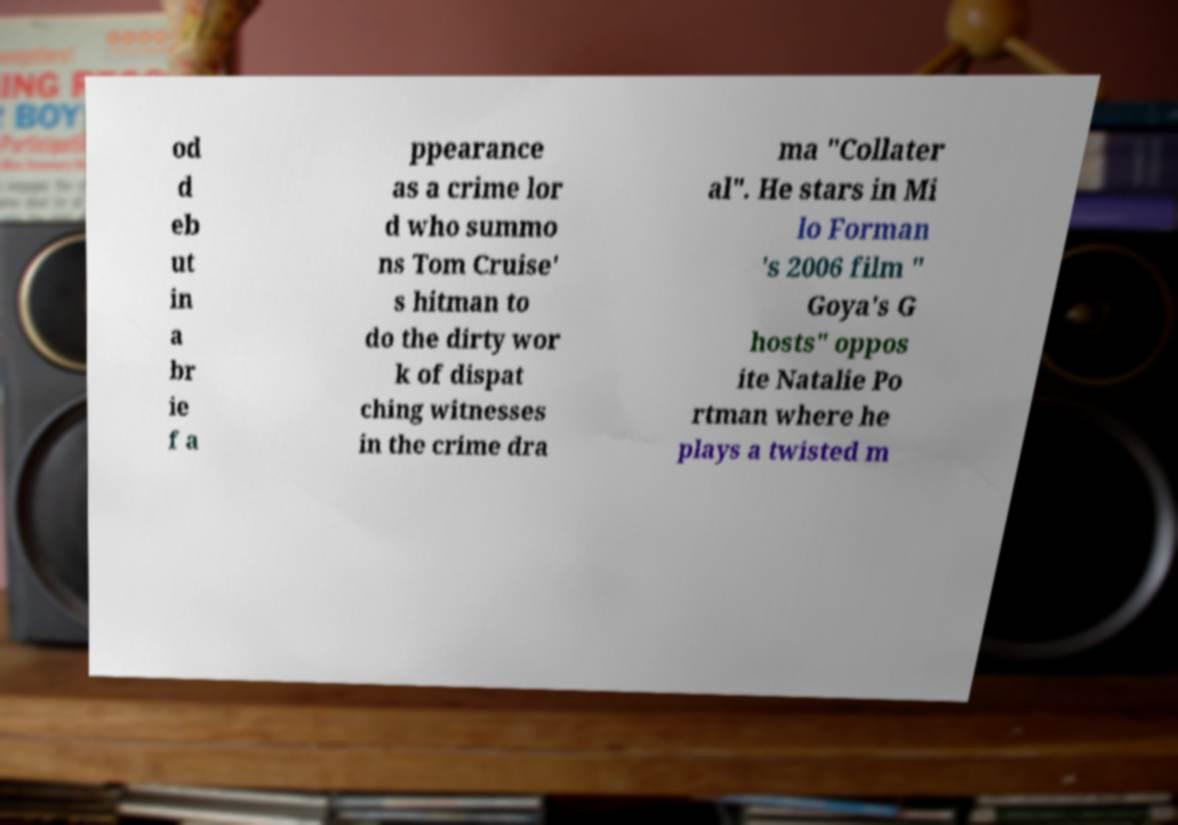Could you extract and type out the text from this image? od d eb ut in a br ie f a ppearance as a crime lor d who summo ns Tom Cruise' s hitman to do the dirty wor k of dispat ching witnesses in the crime dra ma "Collater al". He stars in Mi lo Forman 's 2006 film " Goya's G hosts" oppos ite Natalie Po rtman where he plays a twisted m 